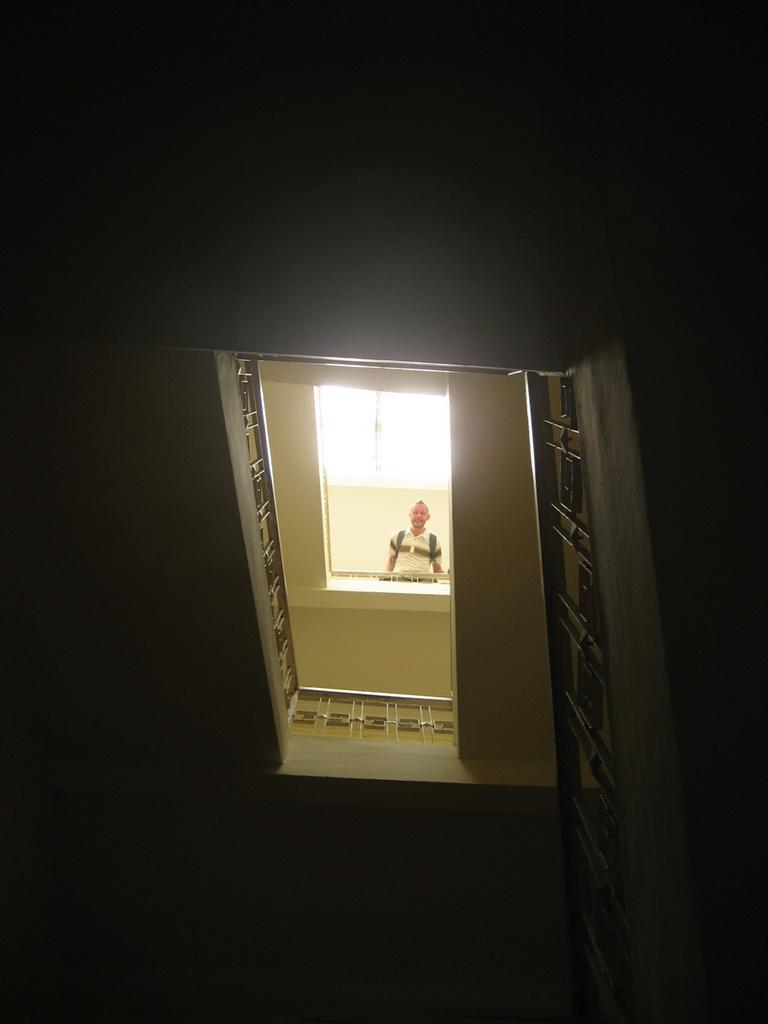What is the main subject of the image? There is a person in the image. What can be seen near the person in the image? There is railing in the image. What is the color of the background in the image? The background of the image is dark. What type of quartz can be seen in the hands of the person in the image? There is no quartz present in the image. Is the person in the image consulting with a lawyer? There is no indication in the image that the person is consulting with a lawyer. Can you see any magical elements in the image? There are no magical elements present in the image. 